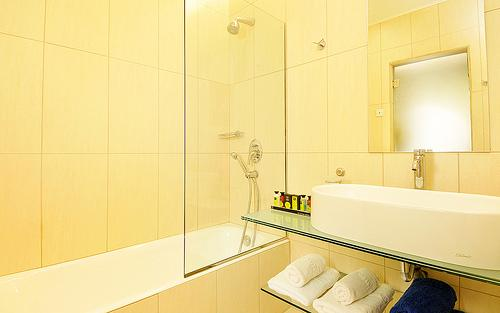Describe the main components of the bathroom without using the words "hotel", "bathroom", "sink", "faucet", or "mirror". A pristine lodging space with a porcelain washbasin, silver spout, bathtub, and wall-mounted reflective surface. Write a short and precise description of the image catering to visitors who appreciate minimalism. Minimal hotel bathroom: clean lines, white color palette, bathtub, sink, towels, faucet, and mirror. Imagine someone walking in to use the bathroom, and describe the image as if you were telling it to them. As you enter, you find an immaculate, inviting space with a sparkling white bathtub, a matching sink, fluffy white towels, and a spacious wall mirror. Viewing the image, what could a prospective guest expect from the hotel room? Guests can expect a clean and comfortable bathroom with ample towels, a sizable sink, and bathtub, along with modern fixtures and fittings. Write a haiku describing the main parts of the image. Bathroom sanctuary. Describe the image from the perspective of a housekeeper entering the room to clean it. Entering the room, I see shining white fixtures alongside neatly folded towels, a sleek faucet, and a well-hung mirror—adding glow to the already pristine space. Mention the color of the towels and the material of the faucet, using simile or metaphor. White as freshly fallen snow, the towels rest, as the faucet glistens like a silver knight's armor. Create a sentence using alliteration to describe the bathroom. The spotless hotel space showcases a sleek sink, beautiful bathtub, pristine porcelain, fresh folded towels, and a vast vanity mirror. Summarize the image by briefly describing its key elements. A clean hotel bathroom featuring a white sink, bathtub, towels, silver faucet, and a wall-mounted mirror. Describe the overarching theme or atmosphere of the image. The image is of a crisp, well-maintained hotel bathroom with a sense of purity and orderliness. 